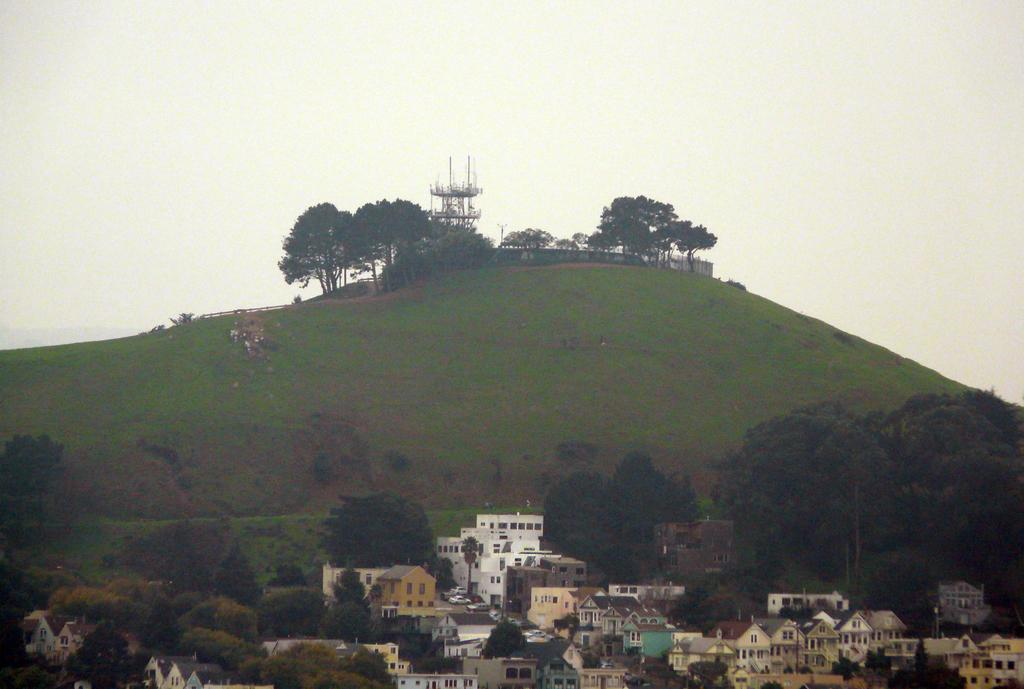What type of structures can be seen in the image? There are buildings in the image. What else is present in the image besides buildings? There are vehicles, trees, a hill, grass, sky, and unspecified objects in the image. Can you describe the natural elements in the image? There are trees, a hill, grass, and sky visible in the image. What type of surface is present in the image? Grass is present in the image. What type of plant is being exchanged between the two individuals in the image? There are no individuals or plants present in the image; it features buildings, vehicles, trees, a hill, grass, and sky. 